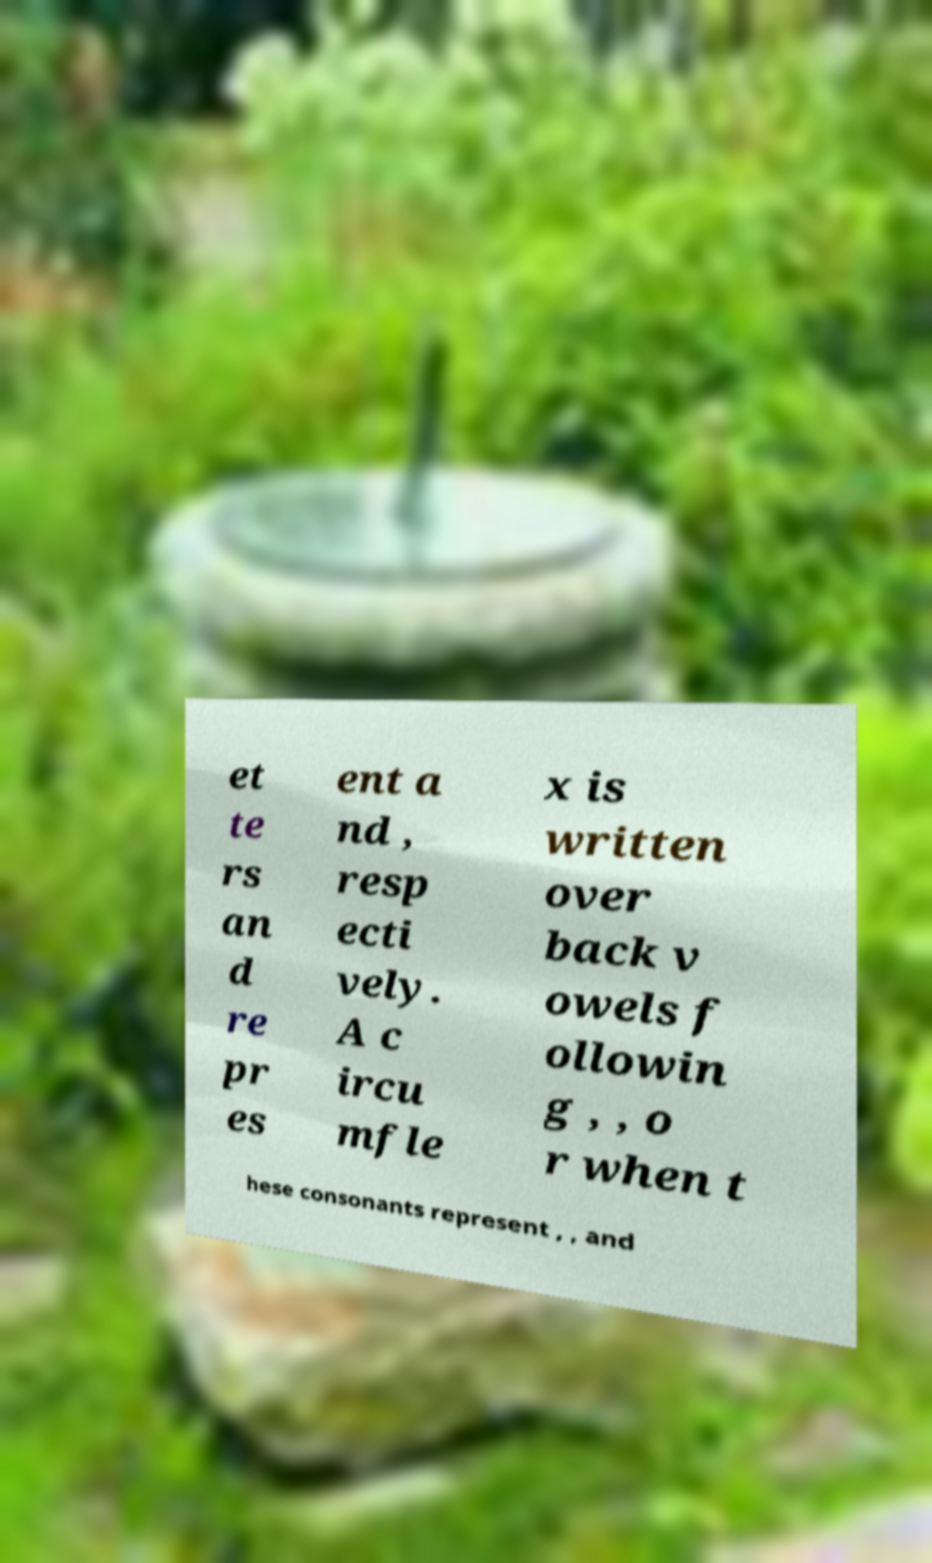Could you assist in decoding the text presented in this image and type it out clearly? et te rs an d re pr es ent a nd , resp ecti vely. A c ircu mfle x is written over back v owels f ollowin g , , o r when t hese consonants represent , , and 